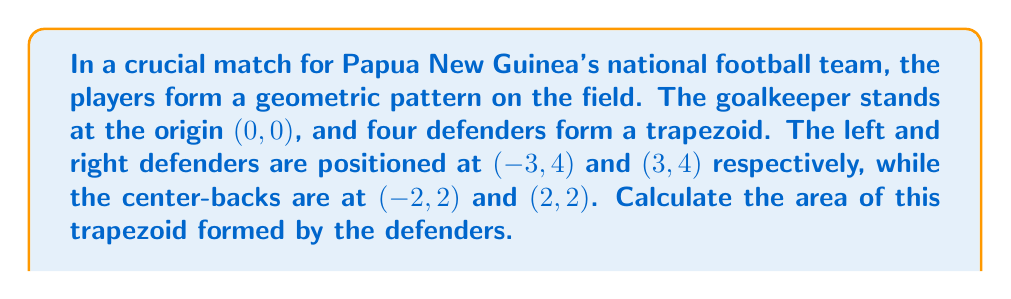Can you answer this question? Let's approach this step-by-step:

1) The trapezoid has parallel sides formed by the lines connecting the left and right defenders, and the two center-backs.

2) To calculate the area of a trapezoid, we use the formula:
   
   $$A = \frac{1}{2}(b_1 + b_2)h$$

   where $A$ is the area, $b_1$ and $b_2$ are the lengths of the parallel sides, and $h$ is the height of the trapezoid.

3) Let's find $b_1$ (distance between left and right defenders):
   $$b_1 = \sqrt{(3-(-3))^2 + (4-4)^2} = \sqrt{36 + 0} = 6$$

4) Now $b_2$ (distance between center-backs):
   $$b_2 = \sqrt{(2-(-2))^2 + (2-2)^2} = \sqrt{16 + 0} = 4$$

5) The height $h$ is the vertical distance between the parallel sides:
   $$h = 4 - 2 = 2$$

6) Now we can plug these values into our area formula:
   $$A = \frac{1}{2}(6 + 4) \cdot 2$$
   $$A = \frac{1}{2}(10) \cdot 2 = 10$$

Therefore, the area of the trapezoid formed by the defenders is 10 square units.
Answer: 10 square units 